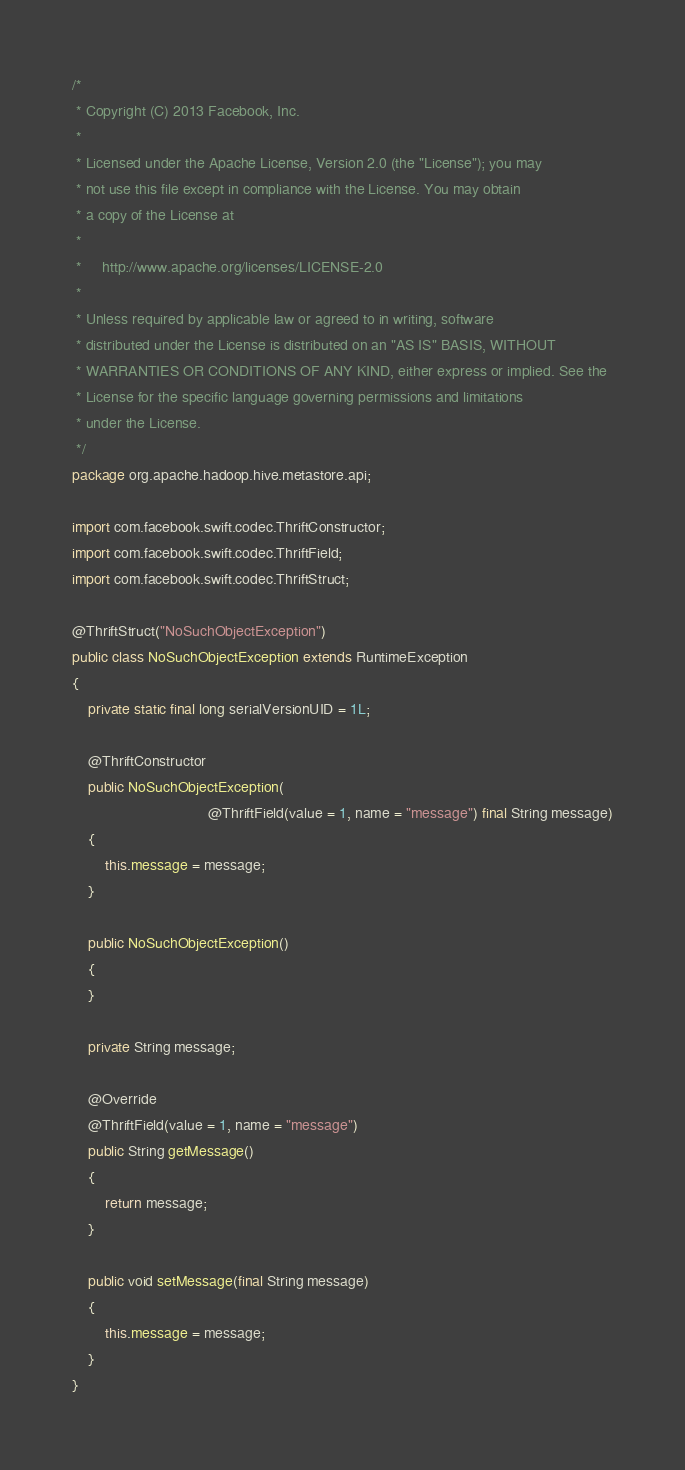Convert code to text. <code><loc_0><loc_0><loc_500><loc_500><_Java_>/*
 * Copyright (C) 2013 Facebook, Inc.
 *
 * Licensed under the Apache License, Version 2.0 (the "License"); you may
 * not use this file except in compliance with the License. You may obtain
 * a copy of the License at
 *
 *     http://www.apache.org/licenses/LICENSE-2.0
 *
 * Unless required by applicable law or agreed to in writing, software
 * distributed under the License is distributed on an "AS IS" BASIS, WITHOUT
 * WARRANTIES OR CONDITIONS OF ANY KIND, either express or implied. See the
 * License for the specific language governing permissions and limitations
 * under the License.
 */
package org.apache.hadoop.hive.metastore.api;

import com.facebook.swift.codec.ThriftConstructor;
import com.facebook.swift.codec.ThriftField;
import com.facebook.swift.codec.ThriftStruct;

@ThriftStruct("NoSuchObjectException")
public class NoSuchObjectException extends RuntimeException
{
    private static final long serialVersionUID = 1L;

    @ThriftConstructor
    public NoSuchObjectException(
                                 @ThriftField(value = 1, name = "message") final String message)
    {
        this.message = message;
    }

    public NoSuchObjectException()
    {
    }

    private String message;

    @Override
    @ThriftField(value = 1, name = "message")
    public String getMessage()
    {
        return message;
    }

    public void setMessage(final String message)
    {
        this.message = message;
    }
}
</code> 